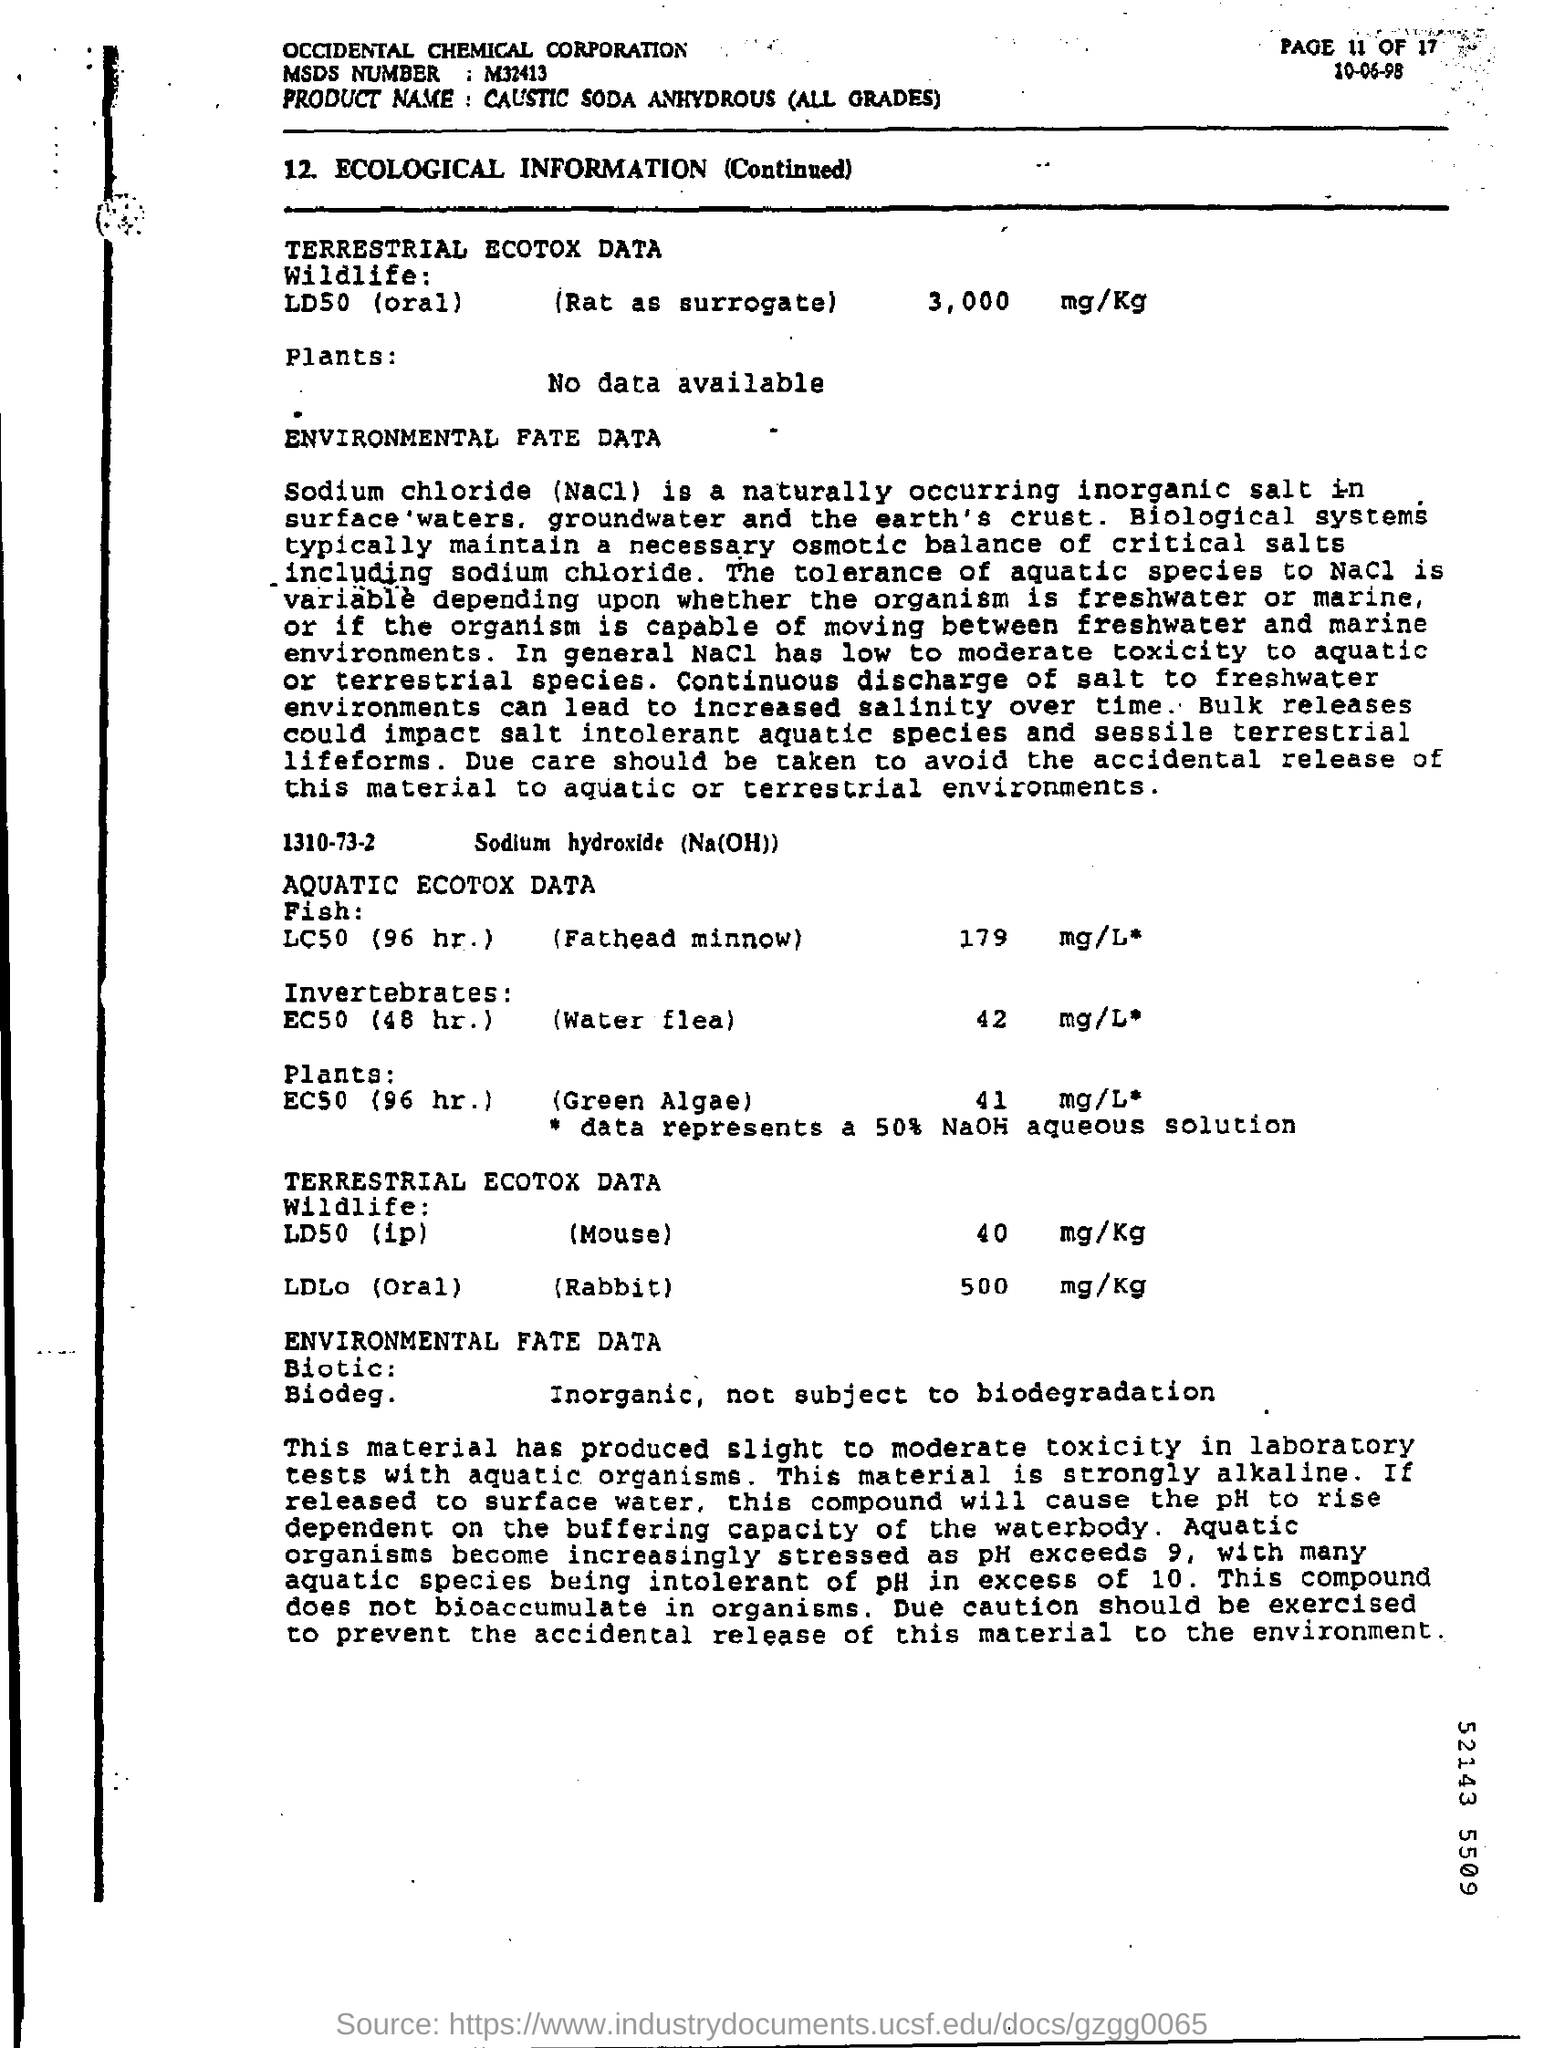Indicate a few pertinent items in this graphic. The product name is Caustic Soda Anhydrous (All Grades). The MSDS number is M32413. 